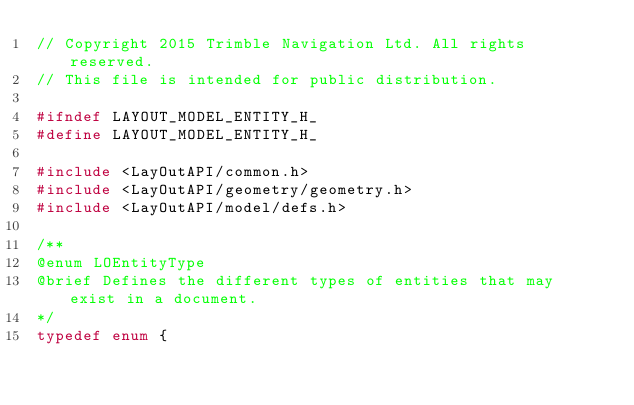Convert code to text. <code><loc_0><loc_0><loc_500><loc_500><_C_>// Copyright 2015 Trimble Navigation Ltd. All rights reserved.
// This file is intended for public distribution.

#ifndef LAYOUT_MODEL_ENTITY_H_
#define LAYOUT_MODEL_ENTITY_H_

#include <LayOutAPI/common.h>
#include <LayOutAPI/geometry/geometry.h>
#include <LayOutAPI/model/defs.h>

/**
@enum LOEntityType
@brief Defines the different types of entities that may exist in a document.
*/
typedef enum {</code> 